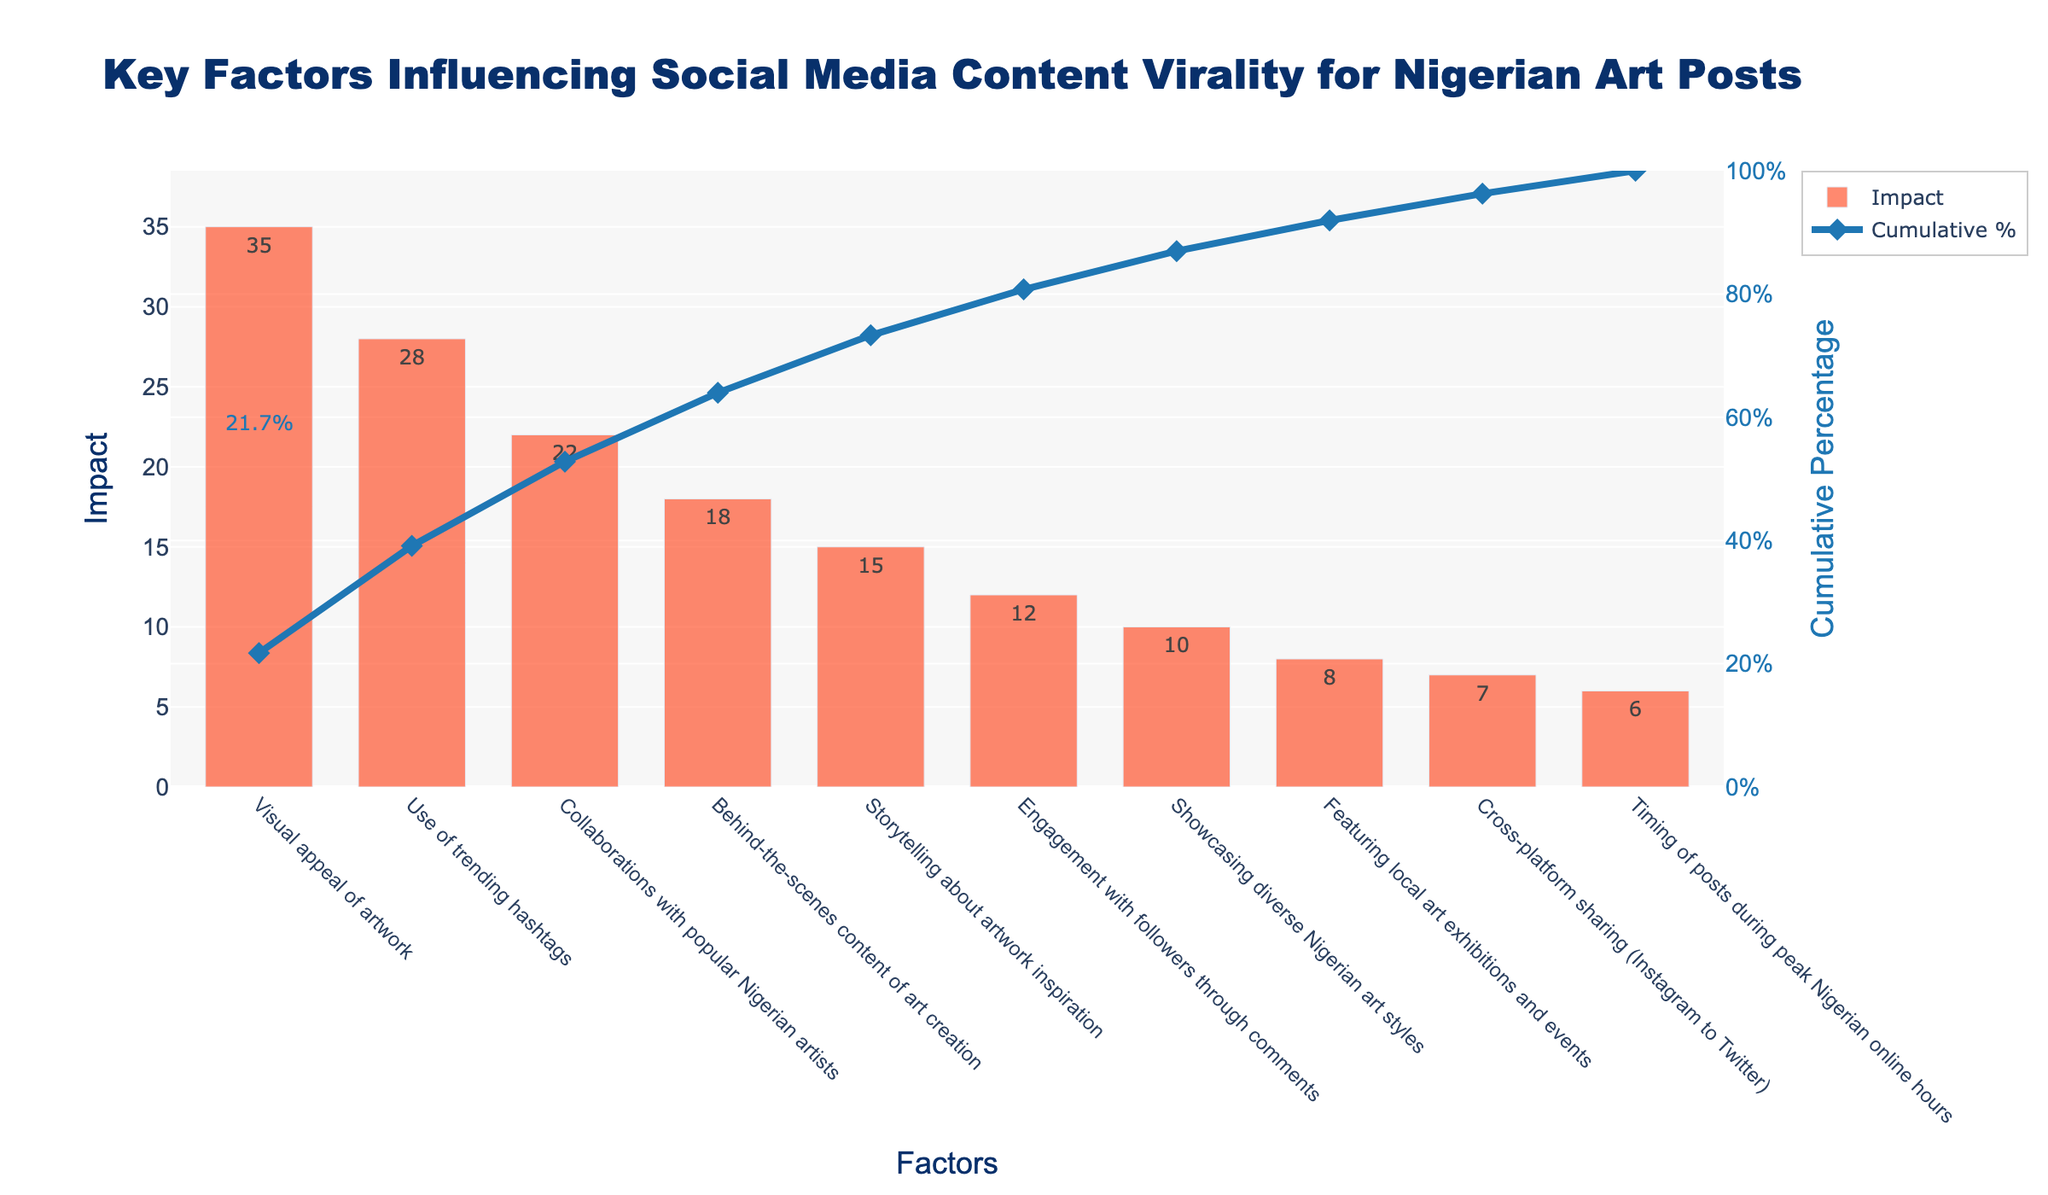What's the title of the plot? The title is displayed at the top of the plot in a larger font. It reads "Key Factors Influencing Social Media Content Virality for Nigerian Art Posts".
Answer: "Key Factors Influencing Social Media Content Virality for Nigerian Art Posts" How many factors are analyzed in the chart? Count the number of bars on the x-axis of the bar chart. There are 10 factors listed.
Answer: 10 Which factor has the highest impact? Look for the tallest bar in the bar chart and identify the corresponding label on the x-axis. The tallest bar corresponds to "Visual appeal of artwork" with an impact of 35.
Answer: "Visual appeal of artwork" What's the impact of "Collaborations with popular Nigerian artists"? Locate the bar labeled "Collaborations with popular Nigerian artists" on the x-axis and read the height of the bar or the text on the bar. It is 22.
Answer: 22 Which factor has the lowest impact? Find the shortest bar in the bar chart and identify the corresponding label on the x-axis. The shortest bar corresponds to "Timing of posts during peak Nigerian online hours" with an impact of 6.
Answer: "Timing of posts during peak Nigerian online hours" What is the cumulative percentage of the top three factors? Sum the impacts of the top three factors: 35 (Visual appeal of artwork) + 28 (Use of trending hashtags) + 22 (Collaborations with popular Nigerian artists) = 85. Then, calculate the cumulative percentage: (85 / 161) * 100 ≈ 52.8%.
Answer: 52.8% Compare the impact of "Engagement with followers through comments" and "Showcasing diverse Nigerian art styles". Which one is higher and by how much? Locate the two bars on the x-axis. "Engagement with followers through comments" has an impact of 12 and "Showcasing diverse Nigerian art styles" has an impact of 10. The difference is 12 - 10 = 2.
Answer: "Engagement with followers through comments", by 2 Which factors contribute to approximately the first 80% of the cumulative impact? Identify the factors contributing to approximately 80% by following the cumulative percentage line until it reaches close to 80%. The factors are "Visual appeal of artwork" (35), "Use of trending hashtags" (28), "Collaborations with popular Nigerian artists" (22), "Behind-the-scenes content of art creation" (18), and "Storytelling about artwork inspiration" (15).
Answer: "Visual appeal of artwork", "Use of trending hashtags", "Collaborations with popular Nigerian artists", "Behind-the-scenes content of art creation", and "Storytelling about artwork inspiration" What is the cumulative percentage after including "Storytelling about artwork inspiration"? Locate "Storytelling about artwork inspiration" on the x-axis and read the cumulative percentage at the top of the bar. It is 73.9%.
Answer: 73.9% What is the total impact of all the factors combined? Sum all the impacts given in the bar chart. Total impact is 35 + 28 + 22 + 18 + 15 + 12 + 10 + 8 + 7 + 6 = 161.
Answer: 161 